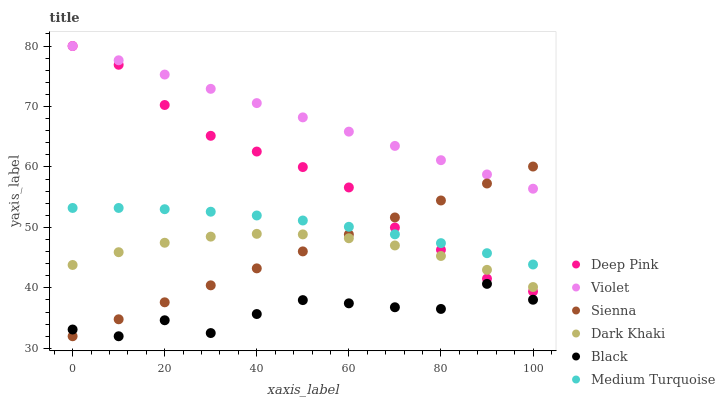Does Black have the minimum area under the curve?
Answer yes or no. Yes. Does Violet have the maximum area under the curve?
Answer yes or no. Yes. Does Deep Pink have the minimum area under the curve?
Answer yes or no. No. Does Deep Pink have the maximum area under the curve?
Answer yes or no. No. Is Violet the smoothest?
Answer yes or no. Yes. Is Black the roughest?
Answer yes or no. Yes. Is Deep Pink the smoothest?
Answer yes or no. No. Is Deep Pink the roughest?
Answer yes or no. No. Does Sienna have the lowest value?
Answer yes or no. Yes. Does Deep Pink have the lowest value?
Answer yes or no. No. Does Violet have the highest value?
Answer yes or no. Yes. Does Sienna have the highest value?
Answer yes or no. No. Is Black less than Medium Turquoise?
Answer yes or no. Yes. Is Dark Khaki greater than Black?
Answer yes or no. Yes. Does Dark Khaki intersect Deep Pink?
Answer yes or no. Yes. Is Dark Khaki less than Deep Pink?
Answer yes or no. No. Is Dark Khaki greater than Deep Pink?
Answer yes or no. No. Does Black intersect Medium Turquoise?
Answer yes or no. No. 